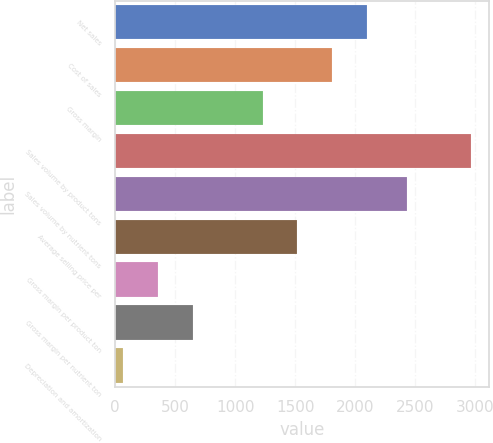Convert chart to OTSL. <chart><loc_0><loc_0><loc_500><loc_500><bar_chart><fcel>Net sales<fcel>Cost of sales<fcel>Gross margin<fcel>Sales volume by product tons<fcel>Sales volume by nutrient tons<fcel>Average selling price per<fcel>Gross margin per product ton<fcel>Gross margin per nutrient ton<fcel>Depreciation and amortization<nl><fcel>2099<fcel>1809<fcel>1229<fcel>2969<fcel>2434<fcel>1519<fcel>359<fcel>649<fcel>69<nl></chart> 